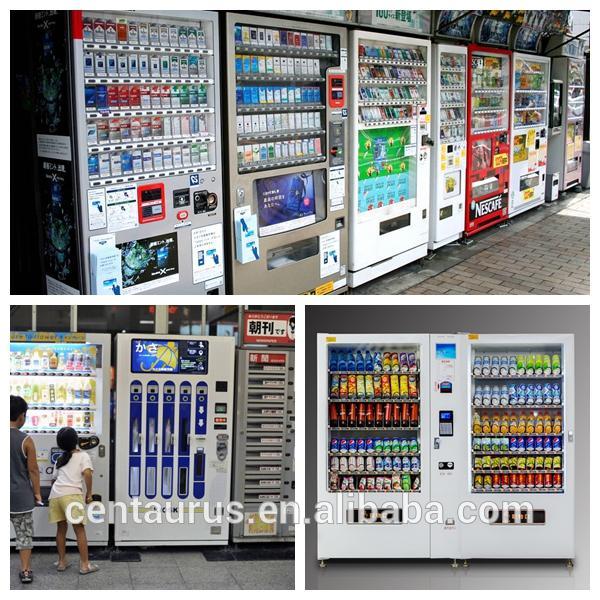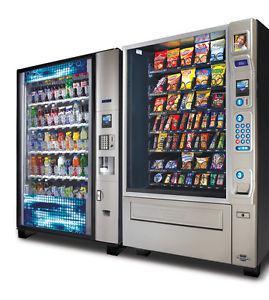The first image is the image on the left, the second image is the image on the right. For the images displayed, is the sentence "One of the image contains one or more vending machines that are facing to the left." factually correct? Answer yes or no. Yes. The first image is the image on the left, the second image is the image on the right. Evaluate the accuracy of this statement regarding the images: "At least one image shows three or more vending machines.". Is it true? Answer yes or no. Yes. 